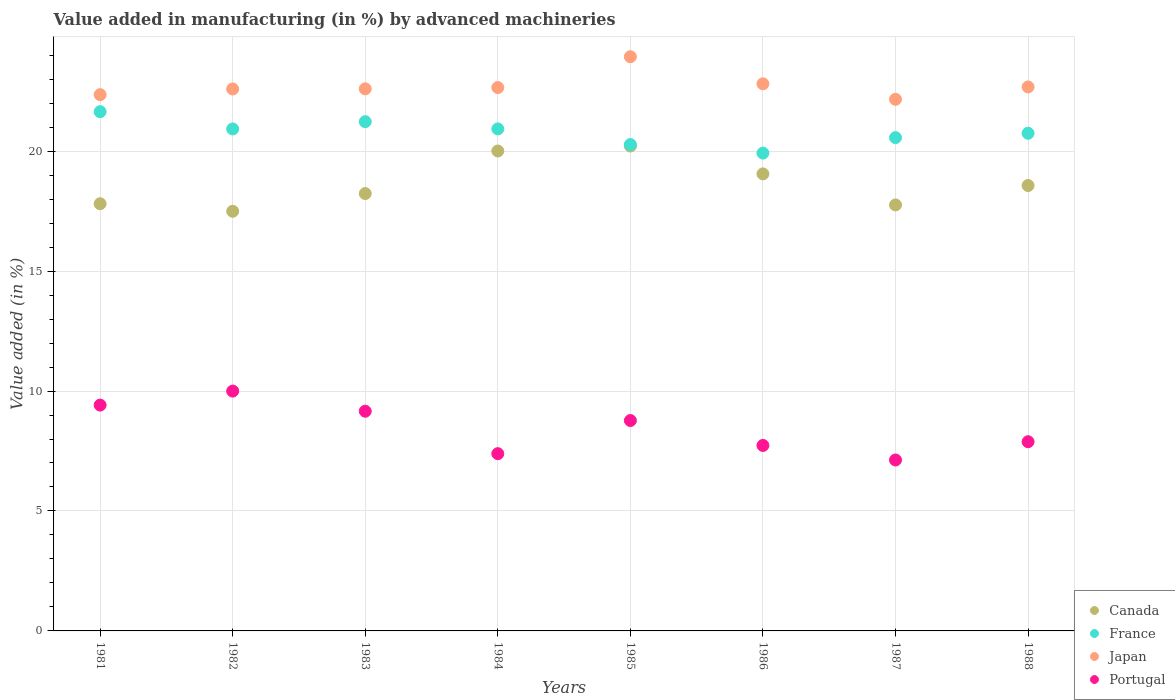Is the number of dotlines equal to the number of legend labels?
Ensure brevity in your answer.  Yes. What is the percentage of value added in manufacturing by advanced machineries in Portugal in 1982?
Give a very brief answer. 10. Across all years, what is the maximum percentage of value added in manufacturing by advanced machineries in Japan?
Your answer should be very brief. 23.94. Across all years, what is the minimum percentage of value added in manufacturing by advanced machineries in Japan?
Offer a terse response. 22.16. In which year was the percentage of value added in manufacturing by advanced machineries in Japan maximum?
Ensure brevity in your answer.  1985. In which year was the percentage of value added in manufacturing by advanced machineries in Portugal minimum?
Your response must be concise. 1987. What is the total percentage of value added in manufacturing by advanced machineries in Portugal in the graph?
Provide a succinct answer. 67.47. What is the difference between the percentage of value added in manufacturing by advanced machineries in Japan in 1981 and that in 1984?
Provide a short and direct response. -0.3. What is the difference between the percentage of value added in manufacturing by advanced machineries in Japan in 1985 and the percentage of value added in manufacturing by advanced machineries in Canada in 1983?
Offer a very short reply. 5.7. What is the average percentage of value added in manufacturing by advanced machineries in Japan per year?
Give a very brief answer. 22.72. In the year 1986, what is the difference between the percentage of value added in manufacturing by advanced machineries in France and percentage of value added in manufacturing by advanced machineries in Canada?
Keep it short and to the point. 0.87. What is the ratio of the percentage of value added in manufacturing by advanced machineries in Japan in 1981 to that in 1985?
Your answer should be very brief. 0.93. Is the difference between the percentage of value added in manufacturing by advanced machineries in France in 1983 and 1988 greater than the difference between the percentage of value added in manufacturing by advanced machineries in Canada in 1983 and 1988?
Make the answer very short. Yes. What is the difference between the highest and the second highest percentage of value added in manufacturing by advanced machineries in Japan?
Provide a short and direct response. 1.13. What is the difference between the highest and the lowest percentage of value added in manufacturing by advanced machineries in Portugal?
Give a very brief answer. 2.87. In how many years, is the percentage of value added in manufacturing by advanced machineries in Japan greater than the average percentage of value added in manufacturing by advanced machineries in Japan taken over all years?
Ensure brevity in your answer.  2. Is the sum of the percentage of value added in manufacturing by advanced machineries in Canada in 1984 and 1986 greater than the maximum percentage of value added in manufacturing by advanced machineries in Japan across all years?
Offer a terse response. Yes. Does the percentage of value added in manufacturing by advanced machineries in Portugal monotonically increase over the years?
Your response must be concise. No. Is the percentage of value added in manufacturing by advanced machineries in Canada strictly less than the percentage of value added in manufacturing by advanced machineries in France over the years?
Offer a terse response. Yes. How many years are there in the graph?
Provide a short and direct response. 8. Are the values on the major ticks of Y-axis written in scientific E-notation?
Keep it short and to the point. No. How many legend labels are there?
Offer a very short reply. 4. How are the legend labels stacked?
Your answer should be compact. Vertical. What is the title of the graph?
Your response must be concise. Value added in manufacturing (in %) by advanced machineries. Does "Puerto Rico" appear as one of the legend labels in the graph?
Your answer should be very brief. No. What is the label or title of the Y-axis?
Your answer should be very brief. Value added (in %). What is the Value added (in %) of Canada in 1981?
Provide a short and direct response. 17.81. What is the Value added (in %) of France in 1981?
Give a very brief answer. 21.64. What is the Value added (in %) in Japan in 1981?
Your answer should be compact. 22.35. What is the Value added (in %) in Portugal in 1981?
Provide a succinct answer. 9.41. What is the Value added (in %) of Canada in 1982?
Keep it short and to the point. 17.49. What is the Value added (in %) of France in 1982?
Give a very brief answer. 20.93. What is the Value added (in %) of Japan in 1982?
Offer a very short reply. 22.59. What is the Value added (in %) in Portugal in 1982?
Your answer should be very brief. 10. What is the Value added (in %) of Canada in 1983?
Offer a very short reply. 18.23. What is the Value added (in %) of France in 1983?
Give a very brief answer. 21.23. What is the Value added (in %) of Japan in 1983?
Your response must be concise. 22.6. What is the Value added (in %) of Portugal in 1983?
Make the answer very short. 9.16. What is the Value added (in %) in Canada in 1984?
Your response must be concise. 20.01. What is the Value added (in %) of France in 1984?
Your answer should be very brief. 20.93. What is the Value added (in %) in Japan in 1984?
Give a very brief answer. 22.65. What is the Value added (in %) of Portugal in 1984?
Make the answer very short. 7.39. What is the Value added (in %) of Canada in 1985?
Your answer should be compact. 20.21. What is the Value added (in %) in France in 1985?
Make the answer very short. 20.28. What is the Value added (in %) of Japan in 1985?
Keep it short and to the point. 23.94. What is the Value added (in %) of Portugal in 1985?
Your response must be concise. 8.77. What is the Value added (in %) of Canada in 1986?
Your response must be concise. 19.05. What is the Value added (in %) of France in 1986?
Your response must be concise. 19.92. What is the Value added (in %) in Japan in 1986?
Ensure brevity in your answer.  22.81. What is the Value added (in %) of Portugal in 1986?
Provide a short and direct response. 7.73. What is the Value added (in %) of Canada in 1987?
Provide a short and direct response. 17.76. What is the Value added (in %) of France in 1987?
Your answer should be very brief. 20.56. What is the Value added (in %) in Japan in 1987?
Provide a succinct answer. 22.16. What is the Value added (in %) of Portugal in 1987?
Your answer should be very brief. 7.13. What is the Value added (in %) in Canada in 1988?
Offer a terse response. 18.57. What is the Value added (in %) in France in 1988?
Offer a terse response. 20.75. What is the Value added (in %) of Japan in 1988?
Keep it short and to the point. 22.68. What is the Value added (in %) in Portugal in 1988?
Offer a very short reply. 7.89. Across all years, what is the maximum Value added (in %) in Canada?
Your response must be concise. 20.21. Across all years, what is the maximum Value added (in %) of France?
Your response must be concise. 21.64. Across all years, what is the maximum Value added (in %) of Japan?
Make the answer very short. 23.94. Across all years, what is the maximum Value added (in %) in Portugal?
Provide a succinct answer. 10. Across all years, what is the minimum Value added (in %) in Canada?
Keep it short and to the point. 17.49. Across all years, what is the minimum Value added (in %) in France?
Offer a very short reply. 19.92. Across all years, what is the minimum Value added (in %) in Japan?
Make the answer very short. 22.16. Across all years, what is the minimum Value added (in %) in Portugal?
Ensure brevity in your answer.  7.13. What is the total Value added (in %) in Canada in the graph?
Offer a terse response. 149.13. What is the total Value added (in %) in France in the graph?
Your answer should be compact. 166.23. What is the total Value added (in %) of Japan in the graph?
Make the answer very short. 181.77. What is the total Value added (in %) of Portugal in the graph?
Provide a short and direct response. 67.47. What is the difference between the Value added (in %) in Canada in 1981 and that in 1982?
Offer a very short reply. 0.31. What is the difference between the Value added (in %) in France in 1981 and that in 1982?
Your answer should be compact. 0.72. What is the difference between the Value added (in %) in Japan in 1981 and that in 1982?
Ensure brevity in your answer.  -0.24. What is the difference between the Value added (in %) in Portugal in 1981 and that in 1982?
Give a very brief answer. -0.58. What is the difference between the Value added (in %) in Canada in 1981 and that in 1983?
Your response must be concise. -0.42. What is the difference between the Value added (in %) of France in 1981 and that in 1983?
Your answer should be very brief. 0.42. What is the difference between the Value added (in %) in Japan in 1981 and that in 1983?
Keep it short and to the point. -0.24. What is the difference between the Value added (in %) in Portugal in 1981 and that in 1983?
Provide a succinct answer. 0.26. What is the difference between the Value added (in %) of Canada in 1981 and that in 1984?
Give a very brief answer. -2.2. What is the difference between the Value added (in %) of France in 1981 and that in 1984?
Your response must be concise. 0.72. What is the difference between the Value added (in %) of Japan in 1981 and that in 1984?
Your answer should be very brief. -0.3. What is the difference between the Value added (in %) of Portugal in 1981 and that in 1984?
Offer a terse response. 2.02. What is the difference between the Value added (in %) of Canada in 1981 and that in 1985?
Your answer should be compact. -2.41. What is the difference between the Value added (in %) of France in 1981 and that in 1985?
Offer a very short reply. 1.37. What is the difference between the Value added (in %) of Japan in 1981 and that in 1985?
Ensure brevity in your answer.  -1.58. What is the difference between the Value added (in %) in Portugal in 1981 and that in 1985?
Your answer should be compact. 0.64. What is the difference between the Value added (in %) of Canada in 1981 and that in 1986?
Your answer should be very brief. -1.24. What is the difference between the Value added (in %) of France in 1981 and that in 1986?
Offer a terse response. 1.73. What is the difference between the Value added (in %) in Japan in 1981 and that in 1986?
Provide a succinct answer. -0.45. What is the difference between the Value added (in %) in Portugal in 1981 and that in 1986?
Offer a terse response. 1.68. What is the difference between the Value added (in %) of Canada in 1981 and that in 1987?
Give a very brief answer. 0.05. What is the difference between the Value added (in %) of France in 1981 and that in 1987?
Offer a terse response. 1.08. What is the difference between the Value added (in %) of Japan in 1981 and that in 1987?
Keep it short and to the point. 0.19. What is the difference between the Value added (in %) of Portugal in 1981 and that in 1987?
Your answer should be compact. 2.29. What is the difference between the Value added (in %) in Canada in 1981 and that in 1988?
Your response must be concise. -0.76. What is the difference between the Value added (in %) of France in 1981 and that in 1988?
Make the answer very short. 0.9. What is the difference between the Value added (in %) of Japan in 1981 and that in 1988?
Offer a very short reply. -0.32. What is the difference between the Value added (in %) in Portugal in 1981 and that in 1988?
Your answer should be very brief. 1.53. What is the difference between the Value added (in %) of Canada in 1982 and that in 1983?
Your response must be concise. -0.74. What is the difference between the Value added (in %) in France in 1982 and that in 1983?
Offer a very short reply. -0.3. What is the difference between the Value added (in %) of Japan in 1982 and that in 1983?
Your answer should be very brief. -0.01. What is the difference between the Value added (in %) in Portugal in 1982 and that in 1983?
Your answer should be very brief. 0.84. What is the difference between the Value added (in %) in Canada in 1982 and that in 1984?
Provide a short and direct response. -2.51. What is the difference between the Value added (in %) of France in 1982 and that in 1984?
Your response must be concise. -0. What is the difference between the Value added (in %) in Japan in 1982 and that in 1984?
Ensure brevity in your answer.  -0.06. What is the difference between the Value added (in %) of Portugal in 1982 and that in 1984?
Provide a short and direct response. 2.61. What is the difference between the Value added (in %) of Canada in 1982 and that in 1985?
Keep it short and to the point. -2.72. What is the difference between the Value added (in %) in France in 1982 and that in 1985?
Ensure brevity in your answer.  0.65. What is the difference between the Value added (in %) of Japan in 1982 and that in 1985?
Your response must be concise. -1.34. What is the difference between the Value added (in %) in Portugal in 1982 and that in 1985?
Ensure brevity in your answer.  1.23. What is the difference between the Value added (in %) in Canada in 1982 and that in 1986?
Give a very brief answer. -1.56. What is the difference between the Value added (in %) in Japan in 1982 and that in 1986?
Offer a terse response. -0.22. What is the difference between the Value added (in %) in Portugal in 1982 and that in 1986?
Make the answer very short. 2.27. What is the difference between the Value added (in %) in Canada in 1982 and that in 1987?
Your answer should be compact. -0.26. What is the difference between the Value added (in %) of France in 1982 and that in 1987?
Your response must be concise. 0.36. What is the difference between the Value added (in %) in Japan in 1982 and that in 1987?
Your response must be concise. 0.43. What is the difference between the Value added (in %) in Portugal in 1982 and that in 1987?
Ensure brevity in your answer.  2.87. What is the difference between the Value added (in %) of Canada in 1982 and that in 1988?
Offer a terse response. -1.07. What is the difference between the Value added (in %) of France in 1982 and that in 1988?
Make the answer very short. 0.18. What is the difference between the Value added (in %) of Japan in 1982 and that in 1988?
Ensure brevity in your answer.  -0.09. What is the difference between the Value added (in %) in Portugal in 1982 and that in 1988?
Offer a terse response. 2.11. What is the difference between the Value added (in %) in Canada in 1983 and that in 1984?
Offer a very short reply. -1.77. What is the difference between the Value added (in %) in France in 1983 and that in 1984?
Offer a very short reply. 0.3. What is the difference between the Value added (in %) of Japan in 1983 and that in 1984?
Provide a succinct answer. -0.05. What is the difference between the Value added (in %) in Portugal in 1983 and that in 1984?
Ensure brevity in your answer.  1.77. What is the difference between the Value added (in %) of Canada in 1983 and that in 1985?
Your answer should be very brief. -1.98. What is the difference between the Value added (in %) of France in 1983 and that in 1985?
Your response must be concise. 0.95. What is the difference between the Value added (in %) in Japan in 1983 and that in 1985?
Make the answer very short. -1.34. What is the difference between the Value added (in %) of Portugal in 1983 and that in 1985?
Offer a very short reply. 0.39. What is the difference between the Value added (in %) in Canada in 1983 and that in 1986?
Ensure brevity in your answer.  -0.82. What is the difference between the Value added (in %) in France in 1983 and that in 1986?
Your response must be concise. 1.31. What is the difference between the Value added (in %) in Japan in 1983 and that in 1986?
Provide a short and direct response. -0.21. What is the difference between the Value added (in %) of Portugal in 1983 and that in 1986?
Your answer should be very brief. 1.43. What is the difference between the Value added (in %) in Canada in 1983 and that in 1987?
Keep it short and to the point. 0.47. What is the difference between the Value added (in %) of France in 1983 and that in 1987?
Your response must be concise. 0.67. What is the difference between the Value added (in %) of Japan in 1983 and that in 1987?
Make the answer very short. 0.44. What is the difference between the Value added (in %) in Portugal in 1983 and that in 1987?
Your answer should be very brief. 2.03. What is the difference between the Value added (in %) in Canada in 1983 and that in 1988?
Your answer should be very brief. -0.33. What is the difference between the Value added (in %) in France in 1983 and that in 1988?
Offer a very short reply. 0.48. What is the difference between the Value added (in %) of Japan in 1983 and that in 1988?
Your response must be concise. -0.08. What is the difference between the Value added (in %) of Portugal in 1983 and that in 1988?
Your answer should be very brief. 1.27. What is the difference between the Value added (in %) of Canada in 1984 and that in 1985?
Ensure brevity in your answer.  -0.21. What is the difference between the Value added (in %) of France in 1984 and that in 1985?
Your response must be concise. 0.65. What is the difference between the Value added (in %) in Japan in 1984 and that in 1985?
Your answer should be compact. -1.28. What is the difference between the Value added (in %) in Portugal in 1984 and that in 1985?
Offer a terse response. -1.38. What is the difference between the Value added (in %) of Canada in 1984 and that in 1986?
Your response must be concise. 0.95. What is the difference between the Value added (in %) in France in 1984 and that in 1986?
Your answer should be compact. 1.01. What is the difference between the Value added (in %) in Japan in 1984 and that in 1986?
Keep it short and to the point. -0.16. What is the difference between the Value added (in %) in Portugal in 1984 and that in 1986?
Your answer should be compact. -0.34. What is the difference between the Value added (in %) of Canada in 1984 and that in 1987?
Provide a succinct answer. 2.25. What is the difference between the Value added (in %) of France in 1984 and that in 1987?
Keep it short and to the point. 0.36. What is the difference between the Value added (in %) in Japan in 1984 and that in 1987?
Ensure brevity in your answer.  0.49. What is the difference between the Value added (in %) in Portugal in 1984 and that in 1987?
Offer a terse response. 0.26. What is the difference between the Value added (in %) in Canada in 1984 and that in 1988?
Offer a very short reply. 1.44. What is the difference between the Value added (in %) of France in 1984 and that in 1988?
Provide a short and direct response. 0.18. What is the difference between the Value added (in %) in Japan in 1984 and that in 1988?
Your answer should be compact. -0.03. What is the difference between the Value added (in %) in Portugal in 1984 and that in 1988?
Provide a succinct answer. -0.5. What is the difference between the Value added (in %) of Canada in 1985 and that in 1986?
Give a very brief answer. 1.16. What is the difference between the Value added (in %) of France in 1985 and that in 1986?
Your answer should be very brief. 0.36. What is the difference between the Value added (in %) in Japan in 1985 and that in 1986?
Provide a succinct answer. 1.13. What is the difference between the Value added (in %) in Portugal in 1985 and that in 1986?
Offer a very short reply. 1.04. What is the difference between the Value added (in %) in Canada in 1985 and that in 1987?
Your answer should be very brief. 2.45. What is the difference between the Value added (in %) of France in 1985 and that in 1987?
Offer a terse response. -0.29. What is the difference between the Value added (in %) in Japan in 1985 and that in 1987?
Offer a very short reply. 1.77. What is the difference between the Value added (in %) in Portugal in 1985 and that in 1987?
Your answer should be compact. 1.64. What is the difference between the Value added (in %) of Canada in 1985 and that in 1988?
Give a very brief answer. 1.65. What is the difference between the Value added (in %) of France in 1985 and that in 1988?
Provide a short and direct response. -0.47. What is the difference between the Value added (in %) in Japan in 1985 and that in 1988?
Your answer should be compact. 1.26. What is the difference between the Value added (in %) in Portugal in 1985 and that in 1988?
Keep it short and to the point. 0.88. What is the difference between the Value added (in %) in Canada in 1986 and that in 1987?
Provide a succinct answer. 1.29. What is the difference between the Value added (in %) in France in 1986 and that in 1987?
Ensure brevity in your answer.  -0.65. What is the difference between the Value added (in %) in Japan in 1986 and that in 1987?
Offer a very short reply. 0.65. What is the difference between the Value added (in %) in Portugal in 1986 and that in 1987?
Offer a terse response. 0.61. What is the difference between the Value added (in %) of Canada in 1986 and that in 1988?
Offer a terse response. 0.49. What is the difference between the Value added (in %) in France in 1986 and that in 1988?
Your answer should be compact. -0.83. What is the difference between the Value added (in %) of Japan in 1986 and that in 1988?
Provide a succinct answer. 0.13. What is the difference between the Value added (in %) of Portugal in 1986 and that in 1988?
Offer a terse response. -0.16. What is the difference between the Value added (in %) of Canada in 1987 and that in 1988?
Provide a succinct answer. -0.81. What is the difference between the Value added (in %) in France in 1987 and that in 1988?
Give a very brief answer. -0.18. What is the difference between the Value added (in %) in Japan in 1987 and that in 1988?
Your answer should be compact. -0.52. What is the difference between the Value added (in %) of Portugal in 1987 and that in 1988?
Offer a terse response. -0.76. What is the difference between the Value added (in %) of Canada in 1981 and the Value added (in %) of France in 1982?
Make the answer very short. -3.12. What is the difference between the Value added (in %) in Canada in 1981 and the Value added (in %) in Japan in 1982?
Ensure brevity in your answer.  -4.78. What is the difference between the Value added (in %) in Canada in 1981 and the Value added (in %) in Portugal in 1982?
Provide a succinct answer. 7.81. What is the difference between the Value added (in %) in France in 1981 and the Value added (in %) in Japan in 1982?
Your answer should be very brief. -0.95. What is the difference between the Value added (in %) of France in 1981 and the Value added (in %) of Portugal in 1982?
Offer a terse response. 11.65. What is the difference between the Value added (in %) of Japan in 1981 and the Value added (in %) of Portugal in 1982?
Provide a short and direct response. 12.36. What is the difference between the Value added (in %) of Canada in 1981 and the Value added (in %) of France in 1983?
Keep it short and to the point. -3.42. What is the difference between the Value added (in %) in Canada in 1981 and the Value added (in %) in Japan in 1983?
Keep it short and to the point. -4.79. What is the difference between the Value added (in %) of Canada in 1981 and the Value added (in %) of Portugal in 1983?
Make the answer very short. 8.65. What is the difference between the Value added (in %) of France in 1981 and the Value added (in %) of Japan in 1983?
Provide a succinct answer. -0.95. What is the difference between the Value added (in %) of France in 1981 and the Value added (in %) of Portugal in 1983?
Provide a short and direct response. 12.49. What is the difference between the Value added (in %) of Japan in 1981 and the Value added (in %) of Portugal in 1983?
Offer a very short reply. 13.2. What is the difference between the Value added (in %) in Canada in 1981 and the Value added (in %) in France in 1984?
Provide a short and direct response. -3.12. What is the difference between the Value added (in %) in Canada in 1981 and the Value added (in %) in Japan in 1984?
Provide a succinct answer. -4.84. What is the difference between the Value added (in %) of Canada in 1981 and the Value added (in %) of Portugal in 1984?
Offer a very short reply. 10.42. What is the difference between the Value added (in %) of France in 1981 and the Value added (in %) of Japan in 1984?
Give a very brief answer. -1.01. What is the difference between the Value added (in %) in France in 1981 and the Value added (in %) in Portugal in 1984?
Your answer should be very brief. 14.26. What is the difference between the Value added (in %) of Japan in 1981 and the Value added (in %) of Portugal in 1984?
Provide a succinct answer. 14.96. What is the difference between the Value added (in %) in Canada in 1981 and the Value added (in %) in France in 1985?
Your response must be concise. -2.47. What is the difference between the Value added (in %) of Canada in 1981 and the Value added (in %) of Japan in 1985?
Offer a very short reply. -6.13. What is the difference between the Value added (in %) of Canada in 1981 and the Value added (in %) of Portugal in 1985?
Your answer should be compact. 9.04. What is the difference between the Value added (in %) in France in 1981 and the Value added (in %) in Japan in 1985?
Ensure brevity in your answer.  -2.29. What is the difference between the Value added (in %) of France in 1981 and the Value added (in %) of Portugal in 1985?
Provide a short and direct response. 12.87. What is the difference between the Value added (in %) of Japan in 1981 and the Value added (in %) of Portugal in 1985?
Your answer should be compact. 13.58. What is the difference between the Value added (in %) of Canada in 1981 and the Value added (in %) of France in 1986?
Give a very brief answer. -2.11. What is the difference between the Value added (in %) in Canada in 1981 and the Value added (in %) in Japan in 1986?
Make the answer very short. -5. What is the difference between the Value added (in %) of Canada in 1981 and the Value added (in %) of Portugal in 1986?
Ensure brevity in your answer.  10.08. What is the difference between the Value added (in %) in France in 1981 and the Value added (in %) in Japan in 1986?
Your response must be concise. -1.16. What is the difference between the Value added (in %) of France in 1981 and the Value added (in %) of Portugal in 1986?
Offer a very short reply. 13.91. What is the difference between the Value added (in %) of Japan in 1981 and the Value added (in %) of Portugal in 1986?
Your answer should be compact. 14.62. What is the difference between the Value added (in %) of Canada in 1981 and the Value added (in %) of France in 1987?
Give a very brief answer. -2.76. What is the difference between the Value added (in %) in Canada in 1981 and the Value added (in %) in Japan in 1987?
Your answer should be very brief. -4.35. What is the difference between the Value added (in %) of Canada in 1981 and the Value added (in %) of Portugal in 1987?
Provide a short and direct response. 10.68. What is the difference between the Value added (in %) of France in 1981 and the Value added (in %) of Japan in 1987?
Offer a very short reply. -0.52. What is the difference between the Value added (in %) of France in 1981 and the Value added (in %) of Portugal in 1987?
Offer a terse response. 14.52. What is the difference between the Value added (in %) of Japan in 1981 and the Value added (in %) of Portugal in 1987?
Offer a very short reply. 15.23. What is the difference between the Value added (in %) of Canada in 1981 and the Value added (in %) of France in 1988?
Offer a very short reply. -2.94. What is the difference between the Value added (in %) of Canada in 1981 and the Value added (in %) of Japan in 1988?
Provide a short and direct response. -4.87. What is the difference between the Value added (in %) in Canada in 1981 and the Value added (in %) in Portugal in 1988?
Make the answer very short. 9.92. What is the difference between the Value added (in %) in France in 1981 and the Value added (in %) in Japan in 1988?
Give a very brief answer. -1.03. What is the difference between the Value added (in %) in France in 1981 and the Value added (in %) in Portugal in 1988?
Offer a terse response. 13.76. What is the difference between the Value added (in %) in Japan in 1981 and the Value added (in %) in Portugal in 1988?
Offer a very short reply. 14.47. What is the difference between the Value added (in %) in Canada in 1982 and the Value added (in %) in France in 1983?
Provide a short and direct response. -3.73. What is the difference between the Value added (in %) in Canada in 1982 and the Value added (in %) in Japan in 1983?
Ensure brevity in your answer.  -5.1. What is the difference between the Value added (in %) of Canada in 1982 and the Value added (in %) of Portugal in 1983?
Ensure brevity in your answer.  8.34. What is the difference between the Value added (in %) in France in 1982 and the Value added (in %) in Japan in 1983?
Your answer should be compact. -1.67. What is the difference between the Value added (in %) in France in 1982 and the Value added (in %) in Portugal in 1983?
Provide a succinct answer. 11.77. What is the difference between the Value added (in %) in Japan in 1982 and the Value added (in %) in Portugal in 1983?
Provide a short and direct response. 13.43. What is the difference between the Value added (in %) in Canada in 1982 and the Value added (in %) in France in 1984?
Make the answer very short. -3.43. What is the difference between the Value added (in %) in Canada in 1982 and the Value added (in %) in Japan in 1984?
Your answer should be very brief. -5.16. What is the difference between the Value added (in %) in Canada in 1982 and the Value added (in %) in Portugal in 1984?
Provide a short and direct response. 10.1. What is the difference between the Value added (in %) in France in 1982 and the Value added (in %) in Japan in 1984?
Keep it short and to the point. -1.72. What is the difference between the Value added (in %) in France in 1982 and the Value added (in %) in Portugal in 1984?
Your answer should be compact. 13.54. What is the difference between the Value added (in %) of Japan in 1982 and the Value added (in %) of Portugal in 1984?
Offer a terse response. 15.2. What is the difference between the Value added (in %) in Canada in 1982 and the Value added (in %) in France in 1985?
Provide a short and direct response. -2.78. What is the difference between the Value added (in %) of Canada in 1982 and the Value added (in %) of Japan in 1985?
Keep it short and to the point. -6.44. What is the difference between the Value added (in %) in Canada in 1982 and the Value added (in %) in Portugal in 1985?
Your response must be concise. 8.72. What is the difference between the Value added (in %) in France in 1982 and the Value added (in %) in Japan in 1985?
Give a very brief answer. -3.01. What is the difference between the Value added (in %) of France in 1982 and the Value added (in %) of Portugal in 1985?
Your answer should be very brief. 12.16. What is the difference between the Value added (in %) in Japan in 1982 and the Value added (in %) in Portugal in 1985?
Your response must be concise. 13.82. What is the difference between the Value added (in %) of Canada in 1982 and the Value added (in %) of France in 1986?
Your answer should be very brief. -2.42. What is the difference between the Value added (in %) in Canada in 1982 and the Value added (in %) in Japan in 1986?
Give a very brief answer. -5.31. What is the difference between the Value added (in %) in Canada in 1982 and the Value added (in %) in Portugal in 1986?
Your answer should be compact. 9.76. What is the difference between the Value added (in %) in France in 1982 and the Value added (in %) in Japan in 1986?
Offer a terse response. -1.88. What is the difference between the Value added (in %) in France in 1982 and the Value added (in %) in Portugal in 1986?
Make the answer very short. 13.19. What is the difference between the Value added (in %) of Japan in 1982 and the Value added (in %) of Portugal in 1986?
Keep it short and to the point. 14.86. What is the difference between the Value added (in %) of Canada in 1982 and the Value added (in %) of France in 1987?
Provide a short and direct response. -3.07. What is the difference between the Value added (in %) in Canada in 1982 and the Value added (in %) in Japan in 1987?
Your response must be concise. -4.67. What is the difference between the Value added (in %) of Canada in 1982 and the Value added (in %) of Portugal in 1987?
Offer a very short reply. 10.37. What is the difference between the Value added (in %) of France in 1982 and the Value added (in %) of Japan in 1987?
Your answer should be very brief. -1.24. What is the difference between the Value added (in %) in France in 1982 and the Value added (in %) in Portugal in 1987?
Offer a terse response. 13.8. What is the difference between the Value added (in %) of Japan in 1982 and the Value added (in %) of Portugal in 1987?
Give a very brief answer. 15.47. What is the difference between the Value added (in %) in Canada in 1982 and the Value added (in %) in France in 1988?
Keep it short and to the point. -3.25. What is the difference between the Value added (in %) of Canada in 1982 and the Value added (in %) of Japan in 1988?
Your answer should be compact. -5.18. What is the difference between the Value added (in %) of Canada in 1982 and the Value added (in %) of Portugal in 1988?
Offer a very short reply. 9.61. What is the difference between the Value added (in %) of France in 1982 and the Value added (in %) of Japan in 1988?
Your answer should be compact. -1.75. What is the difference between the Value added (in %) of France in 1982 and the Value added (in %) of Portugal in 1988?
Your answer should be very brief. 13.04. What is the difference between the Value added (in %) of Japan in 1982 and the Value added (in %) of Portugal in 1988?
Give a very brief answer. 14.7. What is the difference between the Value added (in %) of Canada in 1983 and the Value added (in %) of France in 1984?
Offer a very short reply. -2.69. What is the difference between the Value added (in %) of Canada in 1983 and the Value added (in %) of Japan in 1984?
Your response must be concise. -4.42. What is the difference between the Value added (in %) in Canada in 1983 and the Value added (in %) in Portugal in 1984?
Your response must be concise. 10.84. What is the difference between the Value added (in %) in France in 1983 and the Value added (in %) in Japan in 1984?
Offer a very short reply. -1.42. What is the difference between the Value added (in %) in France in 1983 and the Value added (in %) in Portugal in 1984?
Your response must be concise. 13.84. What is the difference between the Value added (in %) of Japan in 1983 and the Value added (in %) of Portugal in 1984?
Offer a terse response. 15.21. What is the difference between the Value added (in %) of Canada in 1983 and the Value added (in %) of France in 1985?
Your answer should be compact. -2.04. What is the difference between the Value added (in %) in Canada in 1983 and the Value added (in %) in Japan in 1985?
Provide a succinct answer. -5.7. What is the difference between the Value added (in %) of Canada in 1983 and the Value added (in %) of Portugal in 1985?
Your response must be concise. 9.46. What is the difference between the Value added (in %) in France in 1983 and the Value added (in %) in Japan in 1985?
Provide a short and direct response. -2.71. What is the difference between the Value added (in %) in France in 1983 and the Value added (in %) in Portugal in 1985?
Offer a very short reply. 12.46. What is the difference between the Value added (in %) in Japan in 1983 and the Value added (in %) in Portugal in 1985?
Offer a terse response. 13.83. What is the difference between the Value added (in %) in Canada in 1983 and the Value added (in %) in France in 1986?
Your answer should be compact. -1.69. What is the difference between the Value added (in %) in Canada in 1983 and the Value added (in %) in Japan in 1986?
Your answer should be compact. -4.58. What is the difference between the Value added (in %) in Canada in 1983 and the Value added (in %) in Portugal in 1986?
Make the answer very short. 10.5. What is the difference between the Value added (in %) of France in 1983 and the Value added (in %) of Japan in 1986?
Offer a terse response. -1.58. What is the difference between the Value added (in %) of France in 1983 and the Value added (in %) of Portugal in 1986?
Keep it short and to the point. 13.5. What is the difference between the Value added (in %) in Japan in 1983 and the Value added (in %) in Portugal in 1986?
Make the answer very short. 14.87. What is the difference between the Value added (in %) in Canada in 1983 and the Value added (in %) in France in 1987?
Provide a succinct answer. -2.33. What is the difference between the Value added (in %) of Canada in 1983 and the Value added (in %) of Japan in 1987?
Offer a very short reply. -3.93. What is the difference between the Value added (in %) of Canada in 1983 and the Value added (in %) of Portugal in 1987?
Offer a terse response. 11.11. What is the difference between the Value added (in %) of France in 1983 and the Value added (in %) of Japan in 1987?
Offer a very short reply. -0.93. What is the difference between the Value added (in %) in France in 1983 and the Value added (in %) in Portugal in 1987?
Ensure brevity in your answer.  14.1. What is the difference between the Value added (in %) in Japan in 1983 and the Value added (in %) in Portugal in 1987?
Give a very brief answer. 15.47. What is the difference between the Value added (in %) of Canada in 1983 and the Value added (in %) of France in 1988?
Your response must be concise. -2.51. What is the difference between the Value added (in %) of Canada in 1983 and the Value added (in %) of Japan in 1988?
Your answer should be compact. -4.44. What is the difference between the Value added (in %) in Canada in 1983 and the Value added (in %) in Portugal in 1988?
Ensure brevity in your answer.  10.35. What is the difference between the Value added (in %) in France in 1983 and the Value added (in %) in Japan in 1988?
Give a very brief answer. -1.45. What is the difference between the Value added (in %) of France in 1983 and the Value added (in %) of Portugal in 1988?
Offer a very short reply. 13.34. What is the difference between the Value added (in %) of Japan in 1983 and the Value added (in %) of Portugal in 1988?
Provide a succinct answer. 14.71. What is the difference between the Value added (in %) of Canada in 1984 and the Value added (in %) of France in 1985?
Keep it short and to the point. -0.27. What is the difference between the Value added (in %) in Canada in 1984 and the Value added (in %) in Japan in 1985?
Your answer should be compact. -3.93. What is the difference between the Value added (in %) in Canada in 1984 and the Value added (in %) in Portugal in 1985?
Ensure brevity in your answer.  11.24. What is the difference between the Value added (in %) in France in 1984 and the Value added (in %) in Japan in 1985?
Keep it short and to the point. -3.01. What is the difference between the Value added (in %) in France in 1984 and the Value added (in %) in Portugal in 1985?
Your answer should be very brief. 12.16. What is the difference between the Value added (in %) in Japan in 1984 and the Value added (in %) in Portugal in 1985?
Offer a very short reply. 13.88. What is the difference between the Value added (in %) of Canada in 1984 and the Value added (in %) of France in 1986?
Offer a very short reply. 0.09. What is the difference between the Value added (in %) of Canada in 1984 and the Value added (in %) of Japan in 1986?
Offer a terse response. -2.8. What is the difference between the Value added (in %) of Canada in 1984 and the Value added (in %) of Portugal in 1986?
Offer a very short reply. 12.28. What is the difference between the Value added (in %) in France in 1984 and the Value added (in %) in Japan in 1986?
Ensure brevity in your answer.  -1.88. What is the difference between the Value added (in %) in France in 1984 and the Value added (in %) in Portugal in 1986?
Your answer should be compact. 13.2. What is the difference between the Value added (in %) in Japan in 1984 and the Value added (in %) in Portugal in 1986?
Offer a very short reply. 14.92. What is the difference between the Value added (in %) of Canada in 1984 and the Value added (in %) of France in 1987?
Ensure brevity in your answer.  -0.56. What is the difference between the Value added (in %) of Canada in 1984 and the Value added (in %) of Japan in 1987?
Provide a succinct answer. -2.15. What is the difference between the Value added (in %) of Canada in 1984 and the Value added (in %) of Portugal in 1987?
Make the answer very short. 12.88. What is the difference between the Value added (in %) in France in 1984 and the Value added (in %) in Japan in 1987?
Your answer should be compact. -1.23. What is the difference between the Value added (in %) of France in 1984 and the Value added (in %) of Portugal in 1987?
Your answer should be compact. 13.8. What is the difference between the Value added (in %) of Japan in 1984 and the Value added (in %) of Portugal in 1987?
Keep it short and to the point. 15.53. What is the difference between the Value added (in %) of Canada in 1984 and the Value added (in %) of France in 1988?
Provide a succinct answer. -0.74. What is the difference between the Value added (in %) of Canada in 1984 and the Value added (in %) of Japan in 1988?
Offer a very short reply. -2.67. What is the difference between the Value added (in %) of Canada in 1984 and the Value added (in %) of Portugal in 1988?
Your answer should be very brief. 12.12. What is the difference between the Value added (in %) of France in 1984 and the Value added (in %) of Japan in 1988?
Give a very brief answer. -1.75. What is the difference between the Value added (in %) in France in 1984 and the Value added (in %) in Portugal in 1988?
Your response must be concise. 13.04. What is the difference between the Value added (in %) in Japan in 1984 and the Value added (in %) in Portugal in 1988?
Provide a succinct answer. 14.76. What is the difference between the Value added (in %) in Canada in 1985 and the Value added (in %) in France in 1986?
Provide a short and direct response. 0.29. What is the difference between the Value added (in %) of Canada in 1985 and the Value added (in %) of Japan in 1986?
Your response must be concise. -2.59. What is the difference between the Value added (in %) of Canada in 1985 and the Value added (in %) of Portugal in 1986?
Your answer should be very brief. 12.48. What is the difference between the Value added (in %) of France in 1985 and the Value added (in %) of Japan in 1986?
Keep it short and to the point. -2.53. What is the difference between the Value added (in %) in France in 1985 and the Value added (in %) in Portugal in 1986?
Your answer should be compact. 12.54. What is the difference between the Value added (in %) of Japan in 1985 and the Value added (in %) of Portugal in 1986?
Offer a very short reply. 16.2. What is the difference between the Value added (in %) of Canada in 1985 and the Value added (in %) of France in 1987?
Keep it short and to the point. -0.35. What is the difference between the Value added (in %) in Canada in 1985 and the Value added (in %) in Japan in 1987?
Give a very brief answer. -1.95. What is the difference between the Value added (in %) in Canada in 1985 and the Value added (in %) in Portugal in 1987?
Offer a very short reply. 13.09. What is the difference between the Value added (in %) of France in 1985 and the Value added (in %) of Japan in 1987?
Keep it short and to the point. -1.89. What is the difference between the Value added (in %) of France in 1985 and the Value added (in %) of Portugal in 1987?
Provide a succinct answer. 13.15. What is the difference between the Value added (in %) in Japan in 1985 and the Value added (in %) in Portugal in 1987?
Make the answer very short. 16.81. What is the difference between the Value added (in %) in Canada in 1985 and the Value added (in %) in France in 1988?
Ensure brevity in your answer.  -0.53. What is the difference between the Value added (in %) in Canada in 1985 and the Value added (in %) in Japan in 1988?
Give a very brief answer. -2.46. What is the difference between the Value added (in %) in Canada in 1985 and the Value added (in %) in Portugal in 1988?
Your answer should be compact. 12.33. What is the difference between the Value added (in %) of France in 1985 and the Value added (in %) of Japan in 1988?
Provide a succinct answer. -2.4. What is the difference between the Value added (in %) in France in 1985 and the Value added (in %) in Portugal in 1988?
Make the answer very short. 12.39. What is the difference between the Value added (in %) of Japan in 1985 and the Value added (in %) of Portugal in 1988?
Keep it short and to the point. 16.05. What is the difference between the Value added (in %) in Canada in 1986 and the Value added (in %) in France in 1987?
Offer a terse response. -1.51. What is the difference between the Value added (in %) of Canada in 1986 and the Value added (in %) of Japan in 1987?
Make the answer very short. -3.11. What is the difference between the Value added (in %) in Canada in 1986 and the Value added (in %) in Portugal in 1987?
Offer a very short reply. 11.93. What is the difference between the Value added (in %) of France in 1986 and the Value added (in %) of Japan in 1987?
Your answer should be very brief. -2.24. What is the difference between the Value added (in %) of France in 1986 and the Value added (in %) of Portugal in 1987?
Provide a short and direct response. 12.79. What is the difference between the Value added (in %) of Japan in 1986 and the Value added (in %) of Portugal in 1987?
Keep it short and to the point. 15.68. What is the difference between the Value added (in %) in Canada in 1986 and the Value added (in %) in France in 1988?
Offer a very short reply. -1.69. What is the difference between the Value added (in %) in Canada in 1986 and the Value added (in %) in Japan in 1988?
Your response must be concise. -3.62. What is the difference between the Value added (in %) of Canada in 1986 and the Value added (in %) of Portugal in 1988?
Your answer should be very brief. 11.17. What is the difference between the Value added (in %) in France in 1986 and the Value added (in %) in Japan in 1988?
Provide a succinct answer. -2.76. What is the difference between the Value added (in %) of France in 1986 and the Value added (in %) of Portugal in 1988?
Provide a short and direct response. 12.03. What is the difference between the Value added (in %) of Japan in 1986 and the Value added (in %) of Portugal in 1988?
Your answer should be very brief. 14.92. What is the difference between the Value added (in %) of Canada in 1987 and the Value added (in %) of France in 1988?
Keep it short and to the point. -2.99. What is the difference between the Value added (in %) in Canada in 1987 and the Value added (in %) in Japan in 1988?
Your answer should be compact. -4.92. What is the difference between the Value added (in %) of Canada in 1987 and the Value added (in %) of Portugal in 1988?
Your response must be concise. 9.87. What is the difference between the Value added (in %) in France in 1987 and the Value added (in %) in Japan in 1988?
Keep it short and to the point. -2.11. What is the difference between the Value added (in %) in France in 1987 and the Value added (in %) in Portugal in 1988?
Offer a terse response. 12.68. What is the difference between the Value added (in %) in Japan in 1987 and the Value added (in %) in Portugal in 1988?
Give a very brief answer. 14.27. What is the average Value added (in %) in Canada per year?
Offer a terse response. 18.64. What is the average Value added (in %) of France per year?
Keep it short and to the point. 20.78. What is the average Value added (in %) of Japan per year?
Provide a succinct answer. 22.72. What is the average Value added (in %) of Portugal per year?
Make the answer very short. 8.43. In the year 1981, what is the difference between the Value added (in %) of Canada and Value added (in %) of France?
Keep it short and to the point. -3.84. In the year 1981, what is the difference between the Value added (in %) of Canada and Value added (in %) of Japan?
Keep it short and to the point. -4.55. In the year 1981, what is the difference between the Value added (in %) of Canada and Value added (in %) of Portugal?
Make the answer very short. 8.39. In the year 1981, what is the difference between the Value added (in %) in France and Value added (in %) in Japan?
Provide a succinct answer. -0.71. In the year 1981, what is the difference between the Value added (in %) in France and Value added (in %) in Portugal?
Your answer should be very brief. 12.23. In the year 1981, what is the difference between the Value added (in %) of Japan and Value added (in %) of Portugal?
Give a very brief answer. 12.94. In the year 1982, what is the difference between the Value added (in %) in Canada and Value added (in %) in France?
Ensure brevity in your answer.  -3.43. In the year 1982, what is the difference between the Value added (in %) of Canada and Value added (in %) of Japan?
Your answer should be very brief. -5.1. In the year 1982, what is the difference between the Value added (in %) of Canada and Value added (in %) of Portugal?
Offer a very short reply. 7.5. In the year 1982, what is the difference between the Value added (in %) of France and Value added (in %) of Japan?
Give a very brief answer. -1.67. In the year 1982, what is the difference between the Value added (in %) in France and Value added (in %) in Portugal?
Keep it short and to the point. 10.93. In the year 1982, what is the difference between the Value added (in %) in Japan and Value added (in %) in Portugal?
Make the answer very short. 12.59. In the year 1983, what is the difference between the Value added (in %) in Canada and Value added (in %) in France?
Make the answer very short. -3. In the year 1983, what is the difference between the Value added (in %) of Canada and Value added (in %) of Japan?
Provide a short and direct response. -4.36. In the year 1983, what is the difference between the Value added (in %) in Canada and Value added (in %) in Portugal?
Your answer should be very brief. 9.07. In the year 1983, what is the difference between the Value added (in %) of France and Value added (in %) of Japan?
Provide a succinct answer. -1.37. In the year 1983, what is the difference between the Value added (in %) in France and Value added (in %) in Portugal?
Offer a very short reply. 12.07. In the year 1983, what is the difference between the Value added (in %) in Japan and Value added (in %) in Portugal?
Provide a short and direct response. 13.44. In the year 1984, what is the difference between the Value added (in %) in Canada and Value added (in %) in France?
Keep it short and to the point. -0.92. In the year 1984, what is the difference between the Value added (in %) of Canada and Value added (in %) of Japan?
Make the answer very short. -2.64. In the year 1984, what is the difference between the Value added (in %) of Canada and Value added (in %) of Portugal?
Offer a terse response. 12.62. In the year 1984, what is the difference between the Value added (in %) in France and Value added (in %) in Japan?
Offer a very short reply. -1.72. In the year 1984, what is the difference between the Value added (in %) in France and Value added (in %) in Portugal?
Make the answer very short. 13.54. In the year 1984, what is the difference between the Value added (in %) in Japan and Value added (in %) in Portugal?
Make the answer very short. 15.26. In the year 1985, what is the difference between the Value added (in %) in Canada and Value added (in %) in France?
Ensure brevity in your answer.  -0.06. In the year 1985, what is the difference between the Value added (in %) of Canada and Value added (in %) of Japan?
Keep it short and to the point. -3.72. In the year 1985, what is the difference between the Value added (in %) of Canada and Value added (in %) of Portugal?
Your response must be concise. 11.44. In the year 1985, what is the difference between the Value added (in %) of France and Value added (in %) of Japan?
Your answer should be very brief. -3.66. In the year 1985, what is the difference between the Value added (in %) of France and Value added (in %) of Portugal?
Provide a short and direct response. 11.51. In the year 1985, what is the difference between the Value added (in %) in Japan and Value added (in %) in Portugal?
Provide a succinct answer. 15.17. In the year 1986, what is the difference between the Value added (in %) of Canada and Value added (in %) of France?
Your answer should be very brief. -0.87. In the year 1986, what is the difference between the Value added (in %) in Canada and Value added (in %) in Japan?
Make the answer very short. -3.75. In the year 1986, what is the difference between the Value added (in %) of Canada and Value added (in %) of Portugal?
Give a very brief answer. 11.32. In the year 1986, what is the difference between the Value added (in %) in France and Value added (in %) in Japan?
Your answer should be very brief. -2.89. In the year 1986, what is the difference between the Value added (in %) in France and Value added (in %) in Portugal?
Provide a succinct answer. 12.19. In the year 1986, what is the difference between the Value added (in %) in Japan and Value added (in %) in Portugal?
Offer a terse response. 15.08. In the year 1987, what is the difference between the Value added (in %) of Canada and Value added (in %) of France?
Provide a succinct answer. -2.8. In the year 1987, what is the difference between the Value added (in %) of Canada and Value added (in %) of Japan?
Your response must be concise. -4.4. In the year 1987, what is the difference between the Value added (in %) in Canada and Value added (in %) in Portugal?
Your response must be concise. 10.63. In the year 1987, what is the difference between the Value added (in %) of France and Value added (in %) of Japan?
Keep it short and to the point. -1.6. In the year 1987, what is the difference between the Value added (in %) of France and Value added (in %) of Portugal?
Give a very brief answer. 13.44. In the year 1987, what is the difference between the Value added (in %) of Japan and Value added (in %) of Portugal?
Your response must be concise. 15.04. In the year 1988, what is the difference between the Value added (in %) of Canada and Value added (in %) of France?
Your answer should be compact. -2.18. In the year 1988, what is the difference between the Value added (in %) in Canada and Value added (in %) in Japan?
Ensure brevity in your answer.  -4.11. In the year 1988, what is the difference between the Value added (in %) of Canada and Value added (in %) of Portugal?
Give a very brief answer. 10.68. In the year 1988, what is the difference between the Value added (in %) in France and Value added (in %) in Japan?
Provide a short and direct response. -1.93. In the year 1988, what is the difference between the Value added (in %) in France and Value added (in %) in Portugal?
Provide a succinct answer. 12.86. In the year 1988, what is the difference between the Value added (in %) in Japan and Value added (in %) in Portugal?
Your response must be concise. 14.79. What is the ratio of the Value added (in %) of Canada in 1981 to that in 1982?
Offer a terse response. 1.02. What is the ratio of the Value added (in %) of France in 1981 to that in 1982?
Offer a very short reply. 1.03. What is the ratio of the Value added (in %) in Japan in 1981 to that in 1982?
Ensure brevity in your answer.  0.99. What is the ratio of the Value added (in %) of Portugal in 1981 to that in 1982?
Offer a very short reply. 0.94. What is the ratio of the Value added (in %) of Canada in 1981 to that in 1983?
Your answer should be very brief. 0.98. What is the ratio of the Value added (in %) in France in 1981 to that in 1983?
Offer a very short reply. 1.02. What is the ratio of the Value added (in %) of Japan in 1981 to that in 1983?
Offer a terse response. 0.99. What is the ratio of the Value added (in %) in Portugal in 1981 to that in 1983?
Provide a succinct answer. 1.03. What is the ratio of the Value added (in %) of Canada in 1981 to that in 1984?
Make the answer very short. 0.89. What is the ratio of the Value added (in %) of France in 1981 to that in 1984?
Give a very brief answer. 1.03. What is the ratio of the Value added (in %) in Japan in 1981 to that in 1984?
Your response must be concise. 0.99. What is the ratio of the Value added (in %) of Portugal in 1981 to that in 1984?
Provide a short and direct response. 1.27. What is the ratio of the Value added (in %) of Canada in 1981 to that in 1985?
Offer a terse response. 0.88. What is the ratio of the Value added (in %) of France in 1981 to that in 1985?
Provide a succinct answer. 1.07. What is the ratio of the Value added (in %) in Japan in 1981 to that in 1985?
Offer a terse response. 0.93. What is the ratio of the Value added (in %) in Portugal in 1981 to that in 1985?
Your response must be concise. 1.07. What is the ratio of the Value added (in %) of Canada in 1981 to that in 1986?
Offer a terse response. 0.93. What is the ratio of the Value added (in %) of France in 1981 to that in 1986?
Offer a very short reply. 1.09. What is the ratio of the Value added (in %) in Japan in 1981 to that in 1986?
Provide a short and direct response. 0.98. What is the ratio of the Value added (in %) in Portugal in 1981 to that in 1986?
Keep it short and to the point. 1.22. What is the ratio of the Value added (in %) in France in 1981 to that in 1987?
Keep it short and to the point. 1.05. What is the ratio of the Value added (in %) in Japan in 1981 to that in 1987?
Provide a short and direct response. 1.01. What is the ratio of the Value added (in %) of Portugal in 1981 to that in 1987?
Offer a terse response. 1.32. What is the ratio of the Value added (in %) in Canada in 1981 to that in 1988?
Provide a succinct answer. 0.96. What is the ratio of the Value added (in %) of France in 1981 to that in 1988?
Offer a terse response. 1.04. What is the ratio of the Value added (in %) in Japan in 1981 to that in 1988?
Offer a very short reply. 0.99. What is the ratio of the Value added (in %) of Portugal in 1981 to that in 1988?
Give a very brief answer. 1.19. What is the ratio of the Value added (in %) in Canada in 1982 to that in 1983?
Your response must be concise. 0.96. What is the ratio of the Value added (in %) in France in 1982 to that in 1983?
Provide a succinct answer. 0.99. What is the ratio of the Value added (in %) in Portugal in 1982 to that in 1983?
Your answer should be compact. 1.09. What is the ratio of the Value added (in %) of Canada in 1982 to that in 1984?
Offer a terse response. 0.87. What is the ratio of the Value added (in %) in Japan in 1982 to that in 1984?
Your answer should be very brief. 1. What is the ratio of the Value added (in %) of Portugal in 1982 to that in 1984?
Your answer should be compact. 1.35. What is the ratio of the Value added (in %) in Canada in 1982 to that in 1985?
Your answer should be very brief. 0.87. What is the ratio of the Value added (in %) in France in 1982 to that in 1985?
Your response must be concise. 1.03. What is the ratio of the Value added (in %) of Japan in 1982 to that in 1985?
Make the answer very short. 0.94. What is the ratio of the Value added (in %) of Portugal in 1982 to that in 1985?
Give a very brief answer. 1.14. What is the ratio of the Value added (in %) in Canada in 1982 to that in 1986?
Provide a short and direct response. 0.92. What is the ratio of the Value added (in %) in France in 1982 to that in 1986?
Keep it short and to the point. 1.05. What is the ratio of the Value added (in %) of Japan in 1982 to that in 1986?
Offer a very short reply. 0.99. What is the ratio of the Value added (in %) of Portugal in 1982 to that in 1986?
Ensure brevity in your answer.  1.29. What is the ratio of the Value added (in %) in Canada in 1982 to that in 1987?
Make the answer very short. 0.99. What is the ratio of the Value added (in %) in France in 1982 to that in 1987?
Your answer should be very brief. 1.02. What is the ratio of the Value added (in %) of Japan in 1982 to that in 1987?
Ensure brevity in your answer.  1.02. What is the ratio of the Value added (in %) in Portugal in 1982 to that in 1987?
Keep it short and to the point. 1.4. What is the ratio of the Value added (in %) in Canada in 1982 to that in 1988?
Offer a very short reply. 0.94. What is the ratio of the Value added (in %) of France in 1982 to that in 1988?
Provide a succinct answer. 1.01. What is the ratio of the Value added (in %) of Portugal in 1982 to that in 1988?
Your response must be concise. 1.27. What is the ratio of the Value added (in %) of Canada in 1983 to that in 1984?
Offer a very short reply. 0.91. What is the ratio of the Value added (in %) of France in 1983 to that in 1984?
Offer a very short reply. 1.01. What is the ratio of the Value added (in %) of Japan in 1983 to that in 1984?
Give a very brief answer. 1. What is the ratio of the Value added (in %) in Portugal in 1983 to that in 1984?
Ensure brevity in your answer.  1.24. What is the ratio of the Value added (in %) in Canada in 1983 to that in 1985?
Make the answer very short. 0.9. What is the ratio of the Value added (in %) in France in 1983 to that in 1985?
Provide a short and direct response. 1.05. What is the ratio of the Value added (in %) in Japan in 1983 to that in 1985?
Your answer should be compact. 0.94. What is the ratio of the Value added (in %) of Portugal in 1983 to that in 1985?
Provide a succinct answer. 1.04. What is the ratio of the Value added (in %) of Canada in 1983 to that in 1986?
Keep it short and to the point. 0.96. What is the ratio of the Value added (in %) of France in 1983 to that in 1986?
Offer a terse response. 1.07. What is the ratio of the Value added (in %) of Japan in 1983 to that in 1986?
Offer a very short reply. 0.99. What is the ratio of the Value added (in %) in Portugal in 1983 to that in 1986?
Your answer should be compact. 1.18. What is the ratio of the Value added (in %) of Canada in 1983 to that in 1987?
Provide a short and direct response. 1.03. What is the ratio of the Value added (in %) in France in 1983 to that in 1987?
Make the answer very short. 1.03. What is the ratio of the Value added (in %) of Japan in 1983 to that in 1987?
Your response must be concise. 1.02. What is the ratio of the Value added (in %) in Portugal in 1983 to that in 1987?
Offer a very short reply. 1.29. What is the ratio of the Value added (in %) in Canada in 1983 to that in 1988?
Your answer should be very brief. 0.98. What is the ratio of the Value added (in %) in France in 1983 to that in 1988?
Your answer should be compact. 1.02. What is the ratio of the Value added (in %) in Portugal in 1983 to that in 1988?
Ensure brevity in your answer.  1.16. What is the ratio of the Value added (in %) in Canada in 1984 to that in 1985?
Provide a short and direct response. 0.99. What is the ratio of the Value added (in %) in France in 1984 to that in 1985?
Ensure brevity in your answer.  1.03. What is the ratio of the Value added (in %) of Japan in 1984 to that in 1985?
Offer a very short reply. 0.95. What is the ratio of the Value added (in %) in Portugal in 1984 to that in 1985?
Make the answer very short. 0.84. What is the ratio of the Value added (in %) in Canada in 1984 to that in 1986?
Offer a terse response. 1.05. What is the ratio of the Value added (in %) in France in 1984 to that in 1986?
Your answer should be compact. 1.05. What is the ratio of the Value added (in %) of Japan in 1984 to that in 1986?
Make the answer very short. 0.99. What is the ratio of the Value added (in %) in Portugal in 1984 to that in 1986?
Provide a succinct answer. 0.96. What is the ratio of the Value added (in %) in Canada in 1984 to that in 1987?
Give a very brief answer. 1.13. What is the ratio of the Value added (in %) in France in 1984 to that in 1987?
Provide a short and direct response. 1.02. What is the ratio of the Value added (in %) in Japan in 1984 to that in 1987?
Your response must be concise. 1.02. What is the ratio of the Value added (in %) in Portugal in 1984 to that in 1987?
Ensure brevity in your answer.  1.04. What is the ratio of the Value added (in %) of Canada in 1984 to that in 1988?
Offer a terse response. 1.08. What is the ratio of the Value added (in %) in France in 1984 to that in 1988?
Offer a very short reply. 1.01. What is the ratio of the Value added (in %) in Japan in 1984 to that in 1988?
Your response must be concise. 1. What is the ratio of the Value added (in %) in Portugal in 1984 to that in 1988?
Give a very brief answer. 0.94. What is the ratio of the Value added (in %) in Canada in 1985 to that in 1986?
Ensure brevity in your answer.  1.06. What is the ratio of the Value added (in %) in Japan in 1985 to that in 1986?
Make the answer very short. 1.05. What is the ratio of the Value added (in %) in Portugal in 1985 to that in 1986?
Give a very brief answer. 1.13. What is the ratio of the Value added (in %) in Canada in 1985 to that in 1987?
Offer a very short reply. 1.14. What is the ratio of the Value added (in %) of France in 1985 to that in 1987?
Your response must be concise. 0.99. What is the ratio of the Value added (in %) in Japan in 1985 to that in 1987?
Keep it short and to the point. 1.08. What is the ratio of the Value added (in %) of Portugal in 1985 to that in 1987?
Your answer should be compact. 1.23. What is the ratio of the Value added (in %) in Canada in 1985 to that in 1988?
Your answer should be compact. 1.09. What is the ratio of the Value added (in %) in France in 1985 to that in 1988?
Provide a succinct answer. 0.98. What is the ratio of the Value added (in %) in Japan in 1985 to that in 1988?
Your answer should be compact. 1.06. What is the ratio of the Value added (in %) in Portugal in 1985 to that in 1988?
Your response must be concise. 1.11. What is the ratio of the Value added (in %) of Canada in 1986 to that in 1987?
Offer a very short reply. 1.07. What is the ratio of the Value added (in %) of France in 1986 to that in 1987?
Your response must be concise. 0.97. What is the ratio of the Value added (in %) in Japan in 1986 to that in 1987?
Ensure brevity in your answer.  1.03. What is the ratio of the Value added (in %) in Portugal in 1986 to that in 1987?
Make the answer very short. 1.08. What is the ratio of the Value added (in %) in Canada in 1986 to that in 1988?
Your response must be concise. 1.03. What is the ratio of the Value added (in %) of France in 1986 to that in 1988?
Make the answer very short. 0.96. What is the ratio of the Value added (in %) in Japan in 1986 to that in 1988?
Keep it short and to the point. 1.01. What is the ratio of the Value added (in %) of Portugal in 1986 to that in 1988?
Provide a succinct answer. 0.98. What is the ratio of the Value added (in %) in Canada in 1987 to that in 1988?
Provide a short and direct response. 0.96. What is the ratio of the Value added (in %) in Japan in 1987 to that in 1988?
Ensure brevity in your answer.  0.98. What is the ratio of the Value added (in %) of Portugal in 1987 to that in 1988?
Provide a short and direct response. 0.9. What is the difference between the highest and the second highest Value added (in %) of Canada?
Your answer should be very brief. 0.21. What is the difference between the highest and the second highest Value added (in %) of France?
Your answer should be very brief. 0.42. What is the difference between the highest and the second highest Value added (in %) in Japan?
Offer a terse response. 1.13. What is the difference between the highest and the second highest Value added (in %) of Portugal?
Your answer should be compact. 0.58. What is the difference between the highest and the lowest Value added (in %) in Canada?
Keep it short and to the point. 2.72. What is the difference between the highest and the lowest Value added (in %) of France?
Give a very brief answer. 1.73. What is the difference between the highest and the lowest Value added (in %) of Japan?
Make the answer very short. 1.77. What is the difference between the highest and the lowest Value added (in %) of Portugal?
Provide a short and direct response. 2.87. 